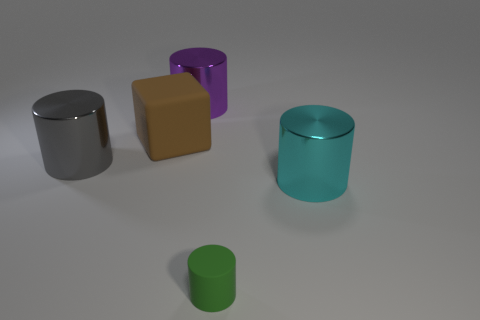There is a tiny cylinder that is made of the same material as the large brown block; what color is it?
Your answer should be compact. Green. There is a large brown object; does it have the same shape as the large metal thing that is on the left side of the large brown matte block?
Your answer should be very brief. No. Are there any purple shiny things on the right side of the big cyan metallic object?
Give a very brief answer. No. Do the purple thing and the rubber object behind the tiny rubber cylinder have the same size?
Ensure brevity in your answer.  Yes. Are there any small metallic cubes of the same color as the small matte cylinder?
Keep it short and to the point. No. Is there a green thing that has the same shape as the gray metal object?
Ensure brevity in your answer.  Yes. What shape is the metallic thing that is both in front of the purple metal cylinder and behind the cyan object?
Offer a terse response. Cylinder. What number of gray things are the same material as the big cyan thing?
Offer a very short reply. 1. Are there fewer big purple cylinders that are behind the tiny green object than green blocks?
Make the answer very short. No. Is there a big gray cylinder that is in front of the object that is on the right side of the matte cylinder?
Your answer should be compact. No. 